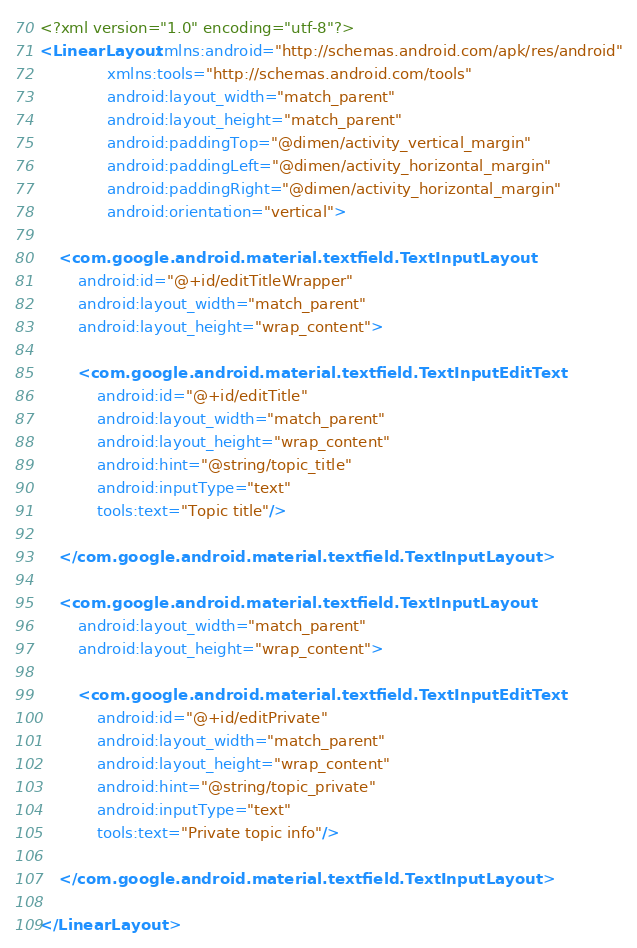<code> <loc_0><loc_0><loc_500><loc_500><_XML_><?xml version="1.0" encoding="utf-8"?>
<LinearLayout xmlns:android="http://schemas.android.com/apk/res/android"
              xmlns:tools="http://schemas.android.com/tools"
              android:layout_width="match_parent"
              android:layout_height="match_parent"
              android:paddingTop="@dimen/activity_vertical_margin"
              android:paddingLeft="@dimen/activity_horizontal_margin"
              android:paddingRight="@dimen/activity_horizontal_margin"
              android:orientation="vertical">

    <com.google.android.material.textfield.TextInputLayout
        android:id="@+id/editTitleWrapper"
        android:layout_width="match_parent"
        android:layout_height="wrap_content">

        <com.google.android.material.textfield.TextInputEditText
            android:id="@+id/editTitle"
            android:layout_width="match_parent"
            android:layout_height="wrap_content"
            android:hint="@string/topic_title"
            android:inputType="text"
            tools:text="Topic title"/>

    </com.google.android.material.textfield.TextInputLayout>

    <com.google.android.material.textfield.TextInputLayout
        android:layout_width="match_parent"
        android:layout_height="wrap_content">

        <com.google.android.material.textfield.TextInputEditText
            android:id="@+id/editPrivate"
            android:layout_width="match_parent"
            android:layout_height="wrap_content"
            android:hint="@string/topic_private"
            android:inputType="text"
            tools:text="Private topic info"/>

    </com.google.android.material.textfield.TextInputLayout>

</LinearLayout></code> 